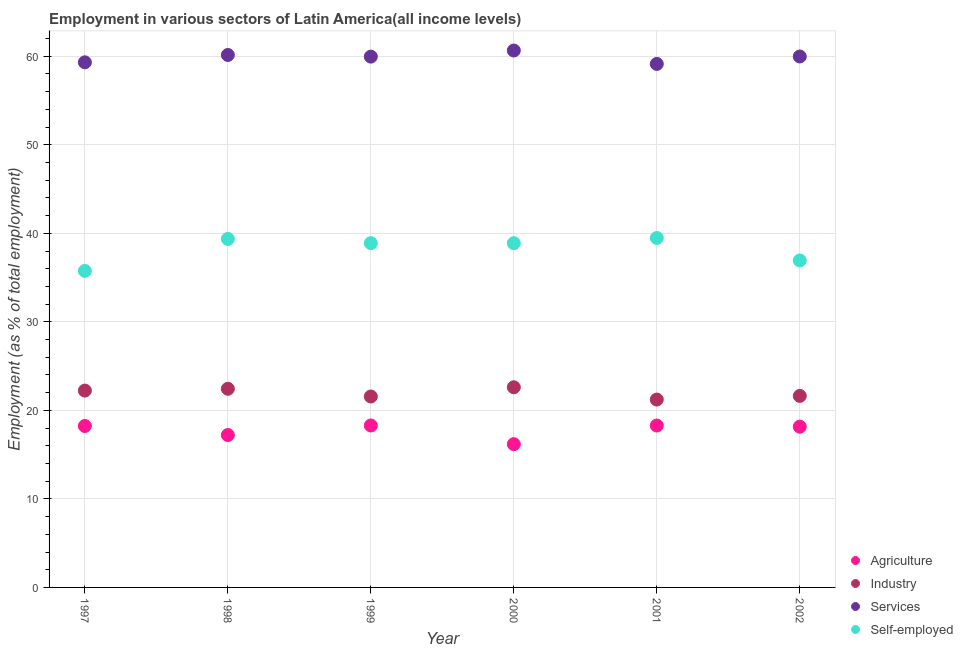How many different coloured dotlines are there?
Provide a succinct answer. 4. What is the percentage of self employed workers in 2002?
Ensure brevity in your answer.  36.93. Across all years, what is the maximum percentage of workers in agriculture?
Your answer should be very brief. 18.29. Across all years, what is the minimum percentage of workers in industry?
Your answer should be very brief. 21.22. In which year was the percentage of workers in industry maximum?
Make the answer very short. 2000. In which year was the percentage of workers in industry minimum?
Provide a succinct answer. 2001. What is the total percentage of self employed workers in the graph?
Keep it short and to the point. 229.3. What is the difference between the percentage of self employed workers in 1997 and that in 1999?
Keep it short and to the point. -3.13. What is the difference between the percentage of workers in services in 2001 and the percentage of self employed workers in 2002?
Make the answer very short. 22.2. What is the average percentage of self employed workers per year?
Provide a short and direct response. 38.22. In the year 1997, what is the difference between the percentage of workers in agriculture and percentage of workers in industry?
Provide a short and direct response. -4. What is the ratio of the percentage of workers in agriculture in 1998 to that in 2002?
Your answer should be very brief. 0.95. Is the difference between the percentage of workers in agriculture in 1997 and 1999 greater than the difference between the percentage of self employed workers in 1997 and 1999?
Your answer should be very brief. Yes. What is the difference between the highest and the second highest percentage of self employed workers?
Make the answer very short. 0.11. What is the difference between the highest and the lowest percentage of workers in services?
Give a very brief answer. 1.51. Is it the case that in every year, the sum of the percentage of workers in agriculture and percentage of workers in services is greater than the sum of percentage of self employed workers and percentage of workers in industry?
Ensure brevity in your answer.  Yes. Does the percentage of self employed workers monotonically increase over the years?
Provide a short and direct response. No. How many dotlines are there?
Offer a very short reply. 4. How many years are there in the graph?
Provide a short and direct response. 6. What is the difference between two consecutive major ticks on the Y-axis?
Make the answer very short. 10. Are the values on the major ticks of Y-axis written in scientific E-notation?
Provide a succinct answer. No. How are the legend labels stacked?
Provide a succinct answer. Vertical. What is the title of the graph?
Ensure brevity in your answer.  Employment in various sectors of Latin America(all income levels). Does "Custom duties" appear as one of the legend labels in the graph?
Offer a terse response. No. What is the label or title of the Y-axis?
Ensure brevity in your answer.  Employment (as % of total employment). What is the Employment (as % of total employment) in Agriculture in 1997?
Your answer should be compact. 18.24. What is the Employment (as % of total employment) of Industry in 1997?
Ensure brevity in your answer.  22.23. What is the Employment (as % of total employment) of Services in 1997?
Make the answer very short. 59.31. What is the Employment (as % of total employment) of Self-employed in 1997?
Your response must be concise. 35.75. What is the Employment (as % of total employment) of Agriculture in 1998?
Your answer should be very brief. 17.21. What is the Employment (as % of total employment) of Industry in 1998?
Offer a terse response. 22.44. What is the Employment (as % of total employment) in Services in 1998?
Ensure brevity in your answer.  60.14. What is the Employment (as % of total employment) in Self-employed in 1998?
Make the answer very short. 39.37. What is the Employment (as % of total employment) in Agriculture in 1999?
Keep it short and to the point. 18.29. What is the Employment (as % of total employment) of Industry in 1999?
Provide a succinct answer. 21.57. What is the Employment (as % of total employment) of Services in 1999?
Your response must be concise. 59.96. What is the Employment (as % of total employment) in Self-employed in 1999?
Make the answer very short. 38.89. What is the Employment (as % of total employment) in Agriculture in 2000?
Provide a succinct answer. 16.18. What is the Employment (as % of total employment) in Industry in 2000?
Your answer should be compact. 22.61. What is the Employment (as % of total employment) of Services in 2000?
Offer a very short reply. 60.65. What is the Employment (as % of total employment) of Self-employed in 2000?
Provide a succinct answer. 38.88. What is the Employment (as % of total employment) of Agriculture in 2001?
Offer a very short reply. 18.29. What is the Employment (as % of total employment) in Industry in 2001?
Provide a short and direct response. 21.22. What is the Employment (as % of total employment) of Services in 2001?
Offer a very short reply. 59.13. What is the Employment (as % of total employment) in Self-employed in 2001?
Provide a short and direct response. 39.47. What is the Employment (as % of total employment) of Agriculture in 2002?
Make the answer very short. 18.16. What is the Employment (as % of total employment) of Industry in 2002?
Offer a very short reply. 21.63. What is the Employment (as % of total employment) of Services in 2002?
Provide a succinct answer. 59.97. What is the Employment (as % of total employment) of Self-employed in 2002?
Ensure brevity in your answer.  36.93. Across all years, what is the maximum Employment (as % of total employment) of Agriculture?
Offer a very short reply. 18.29. Across all years, what is the maximum Employment (as % of total employment) in Industry?
Provide a succinct answer. 22.61. Across all years, what is the maximum Employment (as % of total employment) in Services?
Your answer should be very brief. 60.65. Across all years, what is the maximum Employment (as % of total employment) in Self-employed?
Your answer should be compact. 39.47. Across all years, what is the minimum Employment (as % of total employment) of Agriculture?
Your answer should be compact. 16.18. Across all years, what is the minimum Employment (as % of total employment) of Industry?
Offer a terse response. 21.22. Across all years, what is the minimum Employment (as % of total employment) of Services?
Your response must be concise. 59.13. Across all years, what is the minimum Employment (as % of total employment) of Self-employed?
Provide a succinct answer. 35.75. What is the total Employment (as % of total employment) of Agriculture in the graph?
Offer a very short reply. 106.37. What is the total Employment (as % of total employment) of Industry in the graph?
Offer a very short reply. 131.7. What is the total Employment (as % of total employment) in Services in the graph?
Provide a succinct answer. 359.16. What is the total Employment (as % of total employment) in Self-employed in the graph?
Your response must be concise. 229.3. What is the difference between the Employment (as % of total employment) of Agriculture in 1997 and that in 1998?
Provide a short and direct response. 1.02. What is the difference between the Employment (as % of total employment) of Industry in 1997 and that in 1998?
Your response must be concise. -0.21. What is the difference between the Employment (as % of total employment) of Services in 1997 and that in 1998?
Offer a very short reply. -0.83. What is the difference between the Employment (as % of total employment) of Self-employed in 1997 and that in 1998?
Your answer should be very brief. -3.61. What is the difference between the Employment (as % of total employment) in Agriculture in 1997 and that in 1999?
Your answer should be very brief. -0.06. What is the difference between the Employment (as % of total employment) in Industry in 1997 and that in 1999?
Make the answer very short. 0.67. What is the difference between the Employment (as % of total employment) in Services in 1997 and that in 1999?
Keep it short and to the point. -0.64. What is the difference between the Employment (as % of total employment) in Self-employed in 1997 and that in 1999?
Your answer should be very brief. -3.13. What is the difference between the Employment (as % of total employment) in Agriculture in 1997 and that in 2000?
Keep it short and to the point. 2.05. What is the difference between the Employment (as % of total employment) of Industry in 1997 and that in 2000?
Offer a terse response. -0.38. What is the difference between the Employment (as % of total employment) of Services in 1997 and that in 2000?
Make the answer very short. -1.33. What is the difference between the Employment (as % of total employment) of Self-employed in 1997 and that in 2000?
Provide a short and direct response. -3.13. What is the difference between the Employment (as % of total employment) of Agriculture in 1997 and that in 2001?
Your answer should be compact. -0.05. What is the difference between the Employment (as % of total employment) in Industry in 1997 and that in 2001?
Your answer should be compact. 1.01. What is the difference between the Employment (as % of total employment) in Services in 1997 and that in 2001?
Make the answer very short. 0.18. What is the difference between the Employment (as % of total employment) in Self-employed in 1997 and that in 2001?
Provide a succinct answer. -3.72. What is the difference between the Employment (as % of total employment) of Agriculture in 1997 and that in 2002?
Offer a terse response. 0.08. What is the difference between the Employment (as % of total employment) in Industry in 1997 and that in 2002?
Keep it short and to the point. 0.6. What is the difference between the Employment (as % of total employment) in Services in 1997 and that in 2002?
Offer a terse response. -0.66. What is the difference between the Employment (as % of total employment) of Self-employed in 1997 and that in 2002?
Provide a succinct answer. -1.18. What is the difference between the Employment (as % of total employment) in Agriculture in 1998 and that in 1999?
Your response must be concise. -1.08. What is the difference between the Employment (as % of total employment) in Industry in 1998 and that in 1999?
Offer a terse response. 0.87. What is the difference between the Employment (as % of total employment) of Services in 1998 and that in 1999?
Make the answer very short. 0.18. What is the difference between the Employment (as % of total employment) in Self-employed in 1998 and that in 1999?
Your answer should be very brief. 0.48. What is the difference between the Employment (as % of total employment) in Agriculture in 1998 and that in 2000?
Offer a terse response. 1.03. What is the difference between the Employment (as % of total employment) of Industry in 1998 and that in 2000?
Your answer should be compact. -0.17. What is the difference between the Employment (as % of total employment) of Services in 1998 and that in 2000?
Provide a succinct answer. -0.51. What is the difference between the Employment (as % of total employment) of Self-employed in 1998 and that in 2000?
Offer a terse response. 0.49. What is the difference between the Employment (as % of total employment) in Agriculture in 1998 and that in 2001?
Your response must be concise. -1.07. What is the difference between the Employment (as % of total employment) of Industry in 1998 and that in 2001?
Your response must be concise. 1.22. What is the difference between the Employment (as % of total employment) in Services in 1998 and that in 2001?
Your answer should be compact. 1.01. What is the difference between the Employment (as % of total employment) of Self-employed in 1998 and that in 2001?
Give a very brief answer. -0.11. What is the difference between the Employment (as % of total employment) in Agriculture in 1998 and that in 2002?
Your answer should be very brief. -0.94. What is the difference between the Employment (as % of total employment) of Industry in 1998 and that in 2002?
Give a very brief answer. 0.81. What is the difference between the Employment (as % of total employment) of Services in 1998 and that in 2002?
Your answer should be very brief. 0.17. What is the difference between the Employment (as % of total employment) in Self-employed in 1998 and that in 2002?
Your answer should be very brief. 2.44. What is the difference between the Employment (as % of total employment) of Agriculture in 1999 and that in 2000?
Your response must be concise. 2.11. What is the difference between the Employment (as % of total employment) in Industry in 1999 and that in 2000?
Ensure brevity in your answer.  -1.04. What is the difference between the Employment (as % of total employment) of Services in 1999 and that in 2000?
Offer a terse response. -0.69. What is the difference between the Employment (as % of total employment) of Self-employed in 1999 and that in 2000?
Offer a very short reply. 0.01. What is the difference between the Employment (as % of total employment) of Agriculture in 1999 and that in 2001?
Make the answer very short. 0.01. What is the difference between the Employment (as % of total employment) of Industry in 1999 and that in 2001?
Your response must be concise. 0.34. What is the difference between the Employment (as % of total employment) of Services in 1999 and that in 2001?
Give a very brief answer. 0.82. What is the difference between the Employment (as % of total employment) in Self-employed in 1999 and that in 2001?
Keep it short and to the point. -0.59. What is the difference between the Employment (as % of total employment) of Agriculture in 1999 and that in 2002?
Your answer should be very brief. 0.14. What is the difference between the Employment (as % of total employment) of Industry in 1999 and that in 2002?
Offer a terse response. -0.07. What is the difference between the Employment (as % of total employment) of Services in 1999 and that in 2002?
Provide a succinct answer. -0.02. What is the difference between the Employment (as % of total employment) in Self-employed in 1999 and that in 2002?
Provide a short and direct response. 1.96. What is the difference between the Employment (as % of total employment) in Agriculture in 2000 and that in 2001?
Ensure brevity in your answer.  -2.11. What is the difference between the Employment (as % of total employment) of Industry in 2000 and that in 2001?
Offer a very short reply. 1.39. What is the difference between the Employment (as % of total employment) in Services in 2000 and that in 2001?
Make the answer very short. 1.51. What is the difference between the Employment (as % of total employment) in Self-employed in 2000 and that in 2001?
Give a very brief answer. -0.59. What is the difference between the Employment (as % of total employment) in Agriculture in 2000 and that in 2002?
Make the answer very short. -1.98. What is the difference between the Employment (as % of total employment) of Industry in 2000 and that in 2002?
Offer a terse response. 0.98. What is the difference between the Employment (as % of total employment) of Services in 2000 and that in 2002?
Make the answer very short. 0.67. What is the difference between the Employment (as % of total employment) in Self-employed in 2000 and that in 2002?
Offer a terse response. 1.95. What is the difference between the Employment (as % of total employment) of Agriculture in 2001 and that in 2002?
Your answer should be compact. 0.13. What is the difference between the Employment (as % of total employment) in Industry in 2001 and that in 2002?
Ensure brevity in your answer.  -0.41. What is the difference between the Employment (as % of total employment) of Services in 2001 and that in 2002?
Make the answer very short. -0.84. What is the difference between the Employment (as % of total employment) in Self-employed in 2001 and that in 2002?
Offer a terse response. 2.54. What is the difference between the Employment (as % of total employment) of Agriculture in 1997 and the Employment (as % of total employment) of Industry in 1998?
Your answer should be compact. -4.2. What is the difference between the Employment (as % of total employment) in Agriculture in 1997 and the Employment (as % of total employment) in Services in 1998?
Provide a short and direct response. -41.91. What is the difference between the Employment (as % of total employment) in Agriculture in 1997 and the Employment (as % of total employment) in Self-employed in 1998?
Make the answer very short. -21.13. What is the difference between the Employment (as % of total employment) in Industry in 1997 and the Employment (as % of total employment) in Services in 1998?
Keep it short and to the point. -37.91. What is the difference between the Employment (as % of total employment) in Industry in 1997 and the Employment (as % of total employment) in Self-employed in 1998?
Offer a very short reply. -17.13. What is the difference between the Employment (as % of total employment) of Services in 1997 and the Employment (as % of total employment) of Self-employed in 1998?
Your answer should be compact. 19.95. What is the difference between the Employment (as % of total employment) in Agriculture in 1997 and the Employment (as % of total employment) in Industry in 1999?
Offer a very short reply. -3.33. What is the difference between the Employment (as % of total employment) of Agriculture in 1997 and the Employment (as % of total employment) of Services in 1999?
Provide a succinct answer. -41.72. What is the difference between the Employment (as % of total employment) of Agriculture in 1997 and the Employment (as % of total employment) of Self-employed in 1999?
Make the answer very short. -20.65. What is the difference between the Employment (as % of total employment) of Industry in 1997 and the Employment (as % of total employment) of Services in 1999?
Provide a succinct answer. -37.72. What is the difference between the Employment (as % of total employment) in Industry in 1997 and the Employment (as % of total employment) in Self-employed in 1999?
Provide a short and direct response. -16.65. What is the difference between the Employment (as % of total employment) of Services in 1997 and the Employment (as % of total employment) of Self-employed in 1999?
Your response must be concise. 20.43. What is the difference between the Employment (as % of total employment) in Agriculture in 1997 and the Employment (as % of total employment) in Industry in 2000?
Offer a terse response. -4.37. What is the difference between the Employment (as % of total employment) in Agriculture in 1997 and the Employment (as % of total employment) in Services in 2000?
Offer a very short reply. -42.41. What is the difference between the Employment (as % of total employment) in Agriculture in 1997 and the Employment (as % of total employment) in Self-employed in 2000?
Keep it short and to the point. -20.65. What is the difference between the Employment (as % of total employment) of Industry in 1997 and the Employment (as % of total employment) of Services in 2000?
Provide a succinct answer. -38.41. What is the difference between the Employment (as % of total employment) in Industry in 1997 and the Employment (as % of total employment) in Self-employed in 2000?
Ensure brevity in your answer.  -16.65. What is the difference between the Employment (as % of total employment) of Services in 1997 and the Employment (as % of total employment) of Self-employed in 2000?
Your response must be concise. 20.43. What is the difference between the Employment (as % of total employment) of Agriculture in 1997 and the Employment (as % of total employment) of Industry in 2001?
Make the answer very short. -2.99. What is the difference between the Employment (as % of total employment) in Agriculture in 1997 and the Employment (as % of total employment) in Services in 2001?
Make the answer very short. -40.9. What is the difference between the Employment (as % of total employment) in Agriculture in 1997 and the Employment (as % of total employment) in Self-employed in 2001?
Provide a succinct answer. -21.24. What is the difference between the Employment (as % of total employment) of Industry in 1997 and the Employment (as % of total employment) of Services in 2001?
Offer a very short reply. -36.9. What is the difference between the Employment (as % of total employment) in Industry in 1997 and the Employment (as % of total employment) in Self-employed in 2001?
Offer a terse response. -17.24. What is the difference between the Employment (as % of total employment) in Services in 1997 and the Employment (as % of total employment) in Self-employed in 2001?
Offer a very short reply. 19.84. What is the difference between the Employment (as % of total employment) of Agriculture in 1997 and the Employment (as % of total employment) of Industry in 2002?
Ensure brevity in your answer.  -3.4. What is the difference between the Employment (as % of total employment) of Agriculture in 1997 and the Employment (as % of total employment) of Services in 2002?
Make the answer very short. -41.74. What is the difference between the Employment (as % of total employment) in Agriculture in 1997 and the Employment (as % of total employment) in Self-employed in 2002?
Ensure brevity in your answer.  -18.7. What is the difference between the Employment (as % of total employment) in Industry in 1997 and the Employment (as % of total employment) in Services in 2002?
Your response must be concise. -37.74. What is the difference between the Employment (as % of total employment) in Industry in 1997 and the Employment (as % of total employment) in Self-employed in 2002?
Your answer should be compact. -14.7. What is the difference between the Employment (as % of total employment) in Services in 1997 and the Employment (as % of total employment) in Self-employed in 2002?
Provide a short and direct response. 22.38. What is the difference between the Employment (as % of total employment) of Agriculture in 1998 and the Employment (as % of total employment) of Industry in 1999?
Provide a short and direct response. -4.35. What is the difference between the Employment (as % of total employment) in Agriculture in 1998 and the Employment (as % of total employment) in Services in 1999?
Keep it short and to the point. -42.74. What is the difference between the Employment (as % of total employment) in Agriculture in 1998 and the Employment (as % of total employment) in Self-employed in 1999?
Your response must be concise. -21.67. What is the difference between the Employment (as % of total employment) of Industry in 1998 and the Employment (as % of total employment) of Services in 1999?
Offer a very short reply. -37.52. What is the difference between the Employment (as % of total employment) in Industry in 1998 and the Employment (as % of total employment) in Self-employed in 1999?
Offer a terse response. -16.45. What is the difference between the Employment (as % of total employment) of Services in 1998 and the Employment (as % of total employment) of Self-employed in 1999?
Your answer should be very brief. 21.25. What is the difference between the Employment (as % of total employment) in Agriculture in 1998 and the Employment (as % of total employment) in Industry in 2000?
Give a very brief answer. -5.4. What is the difference between the Employment (as % of total employment) in Agriculture in 1998 and the Employment (as % of total employment) in Services in 2000?
Make the answer very short. -43.43. What is the difference between the Employment (as % of total employment) in Agriculture in 1998 and the Employment (as % of total employment) in Self-employed in 2000?
Your response must be concise. -21.67. What is the difference between the Employment (as % of total employment) of Industry in 1998 and the Employment (as % of total employment) of Services in 2000?
Give a very brief answer. -38.21. What is the difference between the Employment (as % of total employment) of Industry in 1998 and the Employment (as % of total employment) of Self-employed in 2000?
Make the answer very short. -16.44. What is the difference between the Employment (as % of total employment) of Services in 1998 and the Employment (as % of total employment) of Self-employed in 2000?
Make the answer very short. 21.26. What is the difference between the Employment (as % of total employment) in Agriculture in 1998 and the Employment (as % of total employment) in Industry in 2001?
Your response must be concise. -4.01. What is the difference between the Employment (as % of total employment) in Agriculture in 1998 and the Employment (as % of total employment) in Services in 2001?
Provide a succinct answer. -41.92. What is the difference between the Employment (as % of total employment) of Agriculture in 1998 and the Employment (as % of total employment) of Self-employed in 2001?
Keep it short and to the point. -22.26. What is the difference between the Employment (as % of total employment) of Industry in 1998 and the Employment (as % of total employment) of Services in 2001?
Provide a succinct answer. -36.69. What is the difference between the Employment (as % of total employment) of Industry in 1998 and the Employment (as % of total employment) of Self-employed in 2001?
Offer a very short reply. -17.04. What is the difference between the Employment (as % of total employment) of Services in 1998 and the Employment (as % of total employment) of Self-employed in 2001?
Your answer should be compact. 20.67. What is the difference between the Employment (as % of total employment) of Agriculture in 1998 and the Employment (as % of total employment) of Industry in 2002?
Your response must be concise. -4.42. What is the difference between the Employment (as % of total employment) of Agriculture in 1998 and the Employment (as % of total employment) of Services in 2002?
Make the answer very short. -42.76. What is the difference between the Employment (as % of total employment) in Agriculture in 1998 and the Employment (as % of total employment) in Self-employed in 2002?
Make the answer very short. -19.72. What is the difference between the Employment (as % of total employment) of Industry in 1998 and the Employment (as % of total employment) of Services in 2002?
Give a very brief answer. -37.53. What is the difference between the Employment (as % of total employment) in Industry in 1998 and the Employment (as % of total employment) in Self-employed in 2002?
Offer a terse response. -14.49. What is the difference between the Employment (as % of total employment) of Services in 1998 and the Employment (as % of total employment) of Self-employed in 2002?
Your answer should be compact. 23.21. What is the difference between the Employment (as % of total employment) in Agriculture in 1999 and the Employment (as % of total employment) in Industry in 2000?
Offer a very short reply. -4.32. What is the difference between the Employment (as % of total employment) of Agriculture in 1999 and the Employment (as % of total employment) of Services in 2000?
Give a very brief answer. -42.35. What is the difference between the Employment (as % of total employment) in Agriculture in 1999 and the Employment (as % of total employment) in Self-employed in 2000?
Keep it short and to the point. -20.59. What is the difference between the Employment (as % of total employment) in Industry in 1999 and the Employment (as % of total employment) in Services in 2000?
Provide a short and direct response. -39.08. What is the difference between the Employment (as % of total employment) in Industry in 1999 and the Employment (as % of total employment) in Self-employed in 2000?
Give a very brief answer. -17.32. What is the difference between the Employment (as % of total employment) in Services in 1999 and the Employment (as % of total employment) in Self-employed in 2000?
Keep it short and to the point. 21.08. What is the difference between the Employment (as % of total employment) of Agriculture in 1999 and the Employment (as % of total employment) of Industry in 2001?
Provide a succinct answer. -2.93. What is the difference between the Employment (as % of total employment) of Agriculture in 1999 and the Employment (as % of total employment) of Services in 2001?
Your answer should be compact. -40.84. What is the difference between the Employment (as % of total employment) of Agriculture in 1999 and the Employment (as % of total employment) of Self-employed in 2001?
Make the answer very short. -21.18. What is the difference between the Employment (as % of total employment) in Industry in 1999 and the Employment (as % of total employment) in Services in 2001?
Provide a short and direct response. -37.57. What is the difference between the Employment (as % of total employment) of Industry in 1999 and the Employment (as % of total employment) of Self-employed in 2001?
Your response must be concise. -17.91. What is the difference between the Employment (as % of total employment) of Services in 1999 and the Employment (as % of total employment) of Self-employed in 2001?
Offer a very short reply. 20.48. What is the difference between the Employment (as % of total employment) in Agriculture in 1999 and the Employment (as % of total employment) in Industry in 2002?
Ensure brevity in your answer.  -3.34. What is the difference between the Employment (as % of total employment) in Agriculture in 1999 and the Employment (as % of total employment) in Services in 2002?
Your answer should be compact. -41.68. What is the difference between the Employment (as % of total employment) in Agriculture in 1999 and the Employment (as % of total employment) in Self-employed in 2002?
Keep it short and to the point. -18.64. What is the difference between the Employment (as % of total employment) of Industry in 1999 and the Employment (as % of total employment) of Services in 2002?
Give a very brief answer. -38.41. What is the difference between the Employment (as % of total employment) in Industry in 1999 and the Employment (as % of total employment) in Self-employed in 2002?
Your answer should be compact. -15.37. What is the difference between the Employment (as % of total employment) in Services in 1999 and the Employment (as % of total employment) in Self-employed in 2002?
Offer a very short reply. 23.02. What is the difference between the Employment (as % of total employment) in Agriculture in 2000 and the Employment (as % of total employment) in Industry in 2001?
Provide a succinct answer. -5.04. What is the difference between the Employment (as % of total employment) in Agriculture in 2000 and the Employment (as % of total employment) in Services in 2001?
Your answer should be compact. -42.95. What is the difference between the Employment (as % of total employment) of Agriculture in 2000 and the Employment (as % of total employment) of Self-employed in 2001?
Your answer should be compact. -23.29. What is the difference between the Employment (as % of total employment) of Industry in 2000 and the Employment (as % of total employment) of Services in 2001?
Your answer should be very brief. -36.52. What is the difference between the Employment (as % of total employment) of Industry in 2000 and the Employment (as % of total employment) of Self-employed in 2001?
Your response must be concise. -16.86. What is the difference between the Employment (as % of total employment) of Services in 2000 and the Employment (as % of total employment) of Self-employed in 2001?
Provide a short and direct response. 21.17. What is the difference between the Employment (as % of total employment) of Agriculture in 2000 and the Employment (as % of total employment) of Industry in 2002?
Your answer should be compact. -5.45. What is the difference between the Employment (as % of total employment) in Agriculture in 2000 and the Employment (as % of total employment) in Services in 2002?
Your response must be concise. -43.79. What is the difference between the Employment (as % of total employment) in Agriculture in 2000 and the Employment (as % of total employment) in Self-employed in 2002?
Your response must be concise. -20.75. What is the difference between the Employment (as % of total employment) of Industry in 2000 and the Employment (as % of total employment) of Services in 2002?
Your answer should be compact. -37.36. What is the difference between the Employment (as % of total employment) of Industry in 2000 and the Employment (as % of total employment) of Self-employed in 2002?
Make the answer very short. -14.32. What is the difference between the Employment (as % of total employment) of Services in 2000 and the Employment (as % of total employment) of Self-employed in 2002?
Offer a terse response. 23.71. What is the difference between the Employment (as % of total employment) in Agriculture in 2001 and the Employment (as % of total employment) in Industry in 2002?
Give a very brief answer. -3.35. What is the difference between the Employment (as % of total employment) of Agriculture in 2001 and the Employment (as % of total employment) of Services in 2002?
Your answer should be compact. -41.69. What is the difference between the Employment (as % of total employment) in Agriculture in 2001 and the Employment (as % of total employment) in Self-employed in 2002?
Offer a terse response. -18.65. What is the difference between the Employment (as % of total employment) of Industry in 2001 and the Employment (as % of total employment) of Services in 2002?
Offer a terse response. -38.75. What is the difference between the Employment (as % of total employment) of Industry in 2001 and the Employment (as % of total employment) of Self-employed in 2002?
Provide a short and direct response. -15.71. What is the difference between the Employment (as % of total employment) in Services in 2001 and the Employment (as % of total employment) in Self-employed in 2002?
Your answer should be very brief. 22.2. What is the average Employment (as % of total employment) of Agriculture per year?
Your response must be concise. 17.73. What is the average Employment (as % of total employment) in Industry per year?
Offer a terse response. 21.95. What is the average Employment (as % of total employment) in Services per year?
Provide a short and direct response. 59.86. What is the average Employment (as % of total employment) of Self-employed per year?
Your response must be concise. 38.22. In the year 1997, what is the difference between the Employment (as % of total employment) of Agriculture and Employment (as % of total employment) of Industry?
Make the answer very short. -4. In the year 1997, what is the difference between the Employment (as % of total employment) in Agriculture and Employment (as % of total employment) in Services?
Ensure brevity in your answer.  -41.08. In the year 1997, what is the difference between the Employment (as % of total employment) of Agriculture and Employment (as % of total employment) of Self-employed?
Provide a short and direct response. -17.52. In the year 1997, what is the difference between the Employment (as % of total employment) of Industry and Employment (as % of total employment) of Services?
Offer a terse response. -37.08. In the year 1997, what is the difference between the Employment (as % of total employment) of Industry and Employment (as % of total employment) of Self-employed?
Offer a very short reply. -13.52. In the year 1997, what is the difference between the Employment (as % of total employment) of Services and Employment (as % of total employment) of Self-employed?
Give a very brief answer. 23.56. In the year 1998, what is the difference between the Employment (as % of total employment) of Agriculture and Employment (as % of total employment) of Industry?
Provide a short and direct response. -5.23. In the year 1998, what is the difference between the Employment (as % of total employment) in Agriculture and Employment (as % of total employment) in Services?
Your response must be concise. -42.93. In the year 1998, what is the difference between the Employment (as % of total employment) of Agriculture and Employment (as % of total employment) of Self-employed?
Offer a very short reply. -22.15. In the year 1998, what is the difference between the Employment (as % of total employment) in Industry and Employment (as % of total employment) in Services?
Make the answer very short. -37.7. In the year 1998, what is the difference between the Employment (as % of total employment) of Industry and Employment (as % of total employment) of Self-employed?
Make the answer very short. -16.93. In the year 1998, what is the difference between the Employment (as % of total employment) of Services and Employment (as % of total employment) of Self-employed?
Provide a short and direct response. 20.77. In the year 1999, what is the difference between the Employment (as % of total employment) in Agriculture and Employment (as % of total employment) in Industry?
Your response must be concise. -3.27. In the year 1999, what is the difference between the Employment (as % of total employment) in Agriculture and Employment (as % of total employment) in Services?
Ensure brevity in your answer.  -41.66. In the year 1999, what is the difference between the Employment (as % of total employment) of Agriculture and Employment (as % of total employment) of Self-employed?
Your response must be concise. -20.59. In the year 1999, what is the difference between the Employment (as % of total employment) of Industry and Employment (as % of total employment) of Services?
Give a very brief answer. -38.39. In the year 1999, what is the difference between the Employment (as % of total employment) of Industry and Employment (as % of total employment) of Self-employed?
Offer a very short reply. -17.32. In the year 1999, what is the difference between the Employment (as % of total employment) of Services and Employment (as % of total employment) of Self-employed?
Ensure brevity in your answer.  21.07. In the year 2000, what is the difference between the Employment (as % of total employment) in Agriculture and Employment (as % of total employment) in Industry?
Provide a succinct answer. -6.43. In the year 2000, what is the difference between the Employment (as % of total employment) of Agriculture and Employment (as % of total employment) of Services?
Your response must be concise. -44.46. In the year 2000, what is the difference between the Employment (as % of total employment) in Agriculture and Employment (as % of total employment) in Self-employed?
Give a very brief answer. -22.7. In the year 2000, what is the difference between the Employment (as % of total employment) of Industry and Employment (as % of total employment) of Services?
Offer a very short reply. -38.04. In the year 2000, what is the difference between the Employment (as % of total employment) in Industry and Employment (as % of total employment) in Self-employed?
Offer a terse response. -16.27. In the year 2000, what is the difference between the Employment (as % of total employment) in Services and Employment (as % of total employment) in Self-employed?
Provide a short and direct response. 21.77. In the year 2001, what is the difference between the Employment (as % of total employment) of Agriculture and Employment (as % of total employment) of Industry?
Make the answer very short. -2.93. In the year 2001, what is the difference between the Employment (as % of total employment) of Agriculture and Employment (as % of total employment) of Services?
Offer a terse response. -40.84. In the year 2001, what is the difference between the Employment (as % of total employment) of Agriculture and Employment (as % of total employment) of Self-employed?
Give a very brief answer. -21.19. In the year 2001, what is the difference between the Employment (as % of total employment) of Industry and Employment (as % of total employment) of Services?
Your response must be concise. -37.91. In the year 2001, what is the difference between the Employment (as % of total employment) of Industry and Employment (as % of total employment) of Self-employed?
Provide a succinct answer. -18.25. In the year 2001, what is the difference between the Employment (as % of total employment) in Services and Employment (as % of total employment) in Self-employed?
Ensure brevity in your answer.  19.66. In the year 2002, what is the difference between the Employment (as % of total employment) in Agriculture and Employment (as % of total employment) in Industry?
Provide a succinct answer. -3.48. In the year 2002, what is the difference between the Employment (as % of total employment) in Agriculture and Employment (as % of total employment) in Services?
Provide a short and direct response. -41.81. In the year 2002, what is the difference between the Employment (as % of total employment) in Agriculture and Employment (as % of total employment) in Self-employed?
Keep it short and to the point. -18.77. In the year 2002, what is the difference between the Employment (as % of total employment) of Industry and Employment (as % of total employment) of Services?
Offer a very short reply. -38.34. In the year 2002, what is the difference between the Employment (as % of total employment) in Industry and Employment (as % of total employment) in Self-employed?
Provide a succinct answer. -15.3. In the year 2002, what is the difference between the Employment (as % of total employment) of Services and Employment (as % of total employment) of Self-employed?
Give a very brief answer. 23.04. What is the ratio of the Employment (as % of total employment) of Agriculture in 1997 to that in 1998?
Ensure brevity in your answer.  1.06. What is the ratio of the Employment (as % of total employment) in Industry in 1997 to that in 1998?
Your answer should be very brief. 0.99. What is the ratio of the Employment (as % of total employment) in Services in 1997 to that in 1998?
Provide a succinct answer. 0.99. What is the ratio of the Employment (as % of total employment) in Self-employed in 1997 to that in 1998?
Offer a very short reply. 0.91. What is the ratio of the Employment (as % of total employment) of Industry in 1997 to that in 1999?
Make the answer very short. 1.03. What is the ratio of the Employment (as % of total employment) in Services in 1997 to that in 1999?
Your answer should be compact. 0.99. What is the ratio of the Employment (as % of total employment) in Self-employed in 1997 to that in 1999?
Offer a terse response. 0.92. What is the ratio of the Employment (as % of total employment) of Agriculture in 1997 to that in 2000?
Give a very brief answer. 1.13. What is the ratio of the Employment (as % of total employment) in Industry in 1997 to that in 2000?
Provide a succinct answer. 0.98. What is the ratio of the Employment (as % of total employment) in Services in 1997 to that in 2000?
Your answer should be very brief. 0.98. What is the ratio of the Employment (as % of total employment) in Self-employed in 1997 to that in 2000?
Keep it short and to the point. 0.92. What is the ratio of the Employment (as % of total employment) of Industry in 1997 to that in 2001?
Offer a very short reply. 1.05. What is the ratio of the Employment (as % of total employment) of Self-employed in 1997 to that in 2001?
Ensure brevity in your answer.  0.91. What is the ratio of the Employment (as % of total employment) in Agriculture in 1997 to that in 2002?
Your response must be concise. 1. What is the ratio of the Employment (as % of total employment) of Industry in 1997 to that in 2002?
Give a very brief answer. 1.03. What is the ratio of the Employment (as % of total employment) of Self-employed in 1997 to that in 2002?
Your answer should be very brief. 0.97. What is the ratio of the Employment (as % of total employment) in Agriculture in 1998 to that in 1999?
Your answer should be compact. 0.94. What is the ratio of the Employment (as % of total employment) in Industry in 1998 to that in 1999?
Make the answer very short. 1.04. What is the ratio of the Employment (as % of total employment) in Services in 1998 to that in 1999?
Make the answer very short. 1. What is the ratio of the Employment (as % of total employment) in Self-employed in 1998 to that in 1999?
Ensure brevity in your answer.  1.01. What is the ratio of the Employment (as % of total employment) in Agriculture in 1998 to that in 2000?
Keep it short and to the point. 1.06. What is the ratio of the Employment (as % of total employment) of Industry in 1998 to that in 2000?
Your answer should be very brief. 0.99. What is the ratio of the Employment (as % of total employment) of Self-employed in 1998 to that in 2000?
Your answer should be compact. 1.01. What is the ratio of the Employment (as % of total employment) in Agriculture in 1998 to that in 2001?
Offer a terse response. 0.94. What is the ratio of the Employment (as % of total employment) in Industry in 1998 to that in 2001?
Provide a short and direct response. 1.06. What is the ratio of the Employment (as % of total employment) in Services in 1998 to that in 2001?
Your answer should be compact. 1.02. What is the ratio of the Employment (as % of total employment) of Agriculture in 1998 to that in 2002?
Give a very brief answer. 0.95. What is the ratio of the Employment (as % of total employment) of Industry in 1998 to that in 2002?
Ensure brevity in your answer.  1.04. What is the ratio of the Employment (as % of total employment) of Services in 1998 to that in 2002?
Offer a very short reply. 1. What is the ratio of the Employment (as % of total employment) of Self-employed in 1998 to that in 2002?
Provide a succinct answer. 1.07. What is the ratio of the Employment (as % of total employment) in Agriculture in 1999 to that in 2000?
Offer a terse response. 1.13. What is the ratio of the Employment (as % of total employment) in Industry in 1999 to that in 2000?
Your answer should be compact. 0.95. What is the ratio of the Employment (as % of total employment) in Services in 1999 to that in 2000?
Your response must be concise. 0.99. What is the ratio of the Employment (as % of total employment) of Self-employed in 1999 to that in 2000?
Keep it short and to the point. 1. What is the ratio of the Employment (as % of total employment) in Industry in 1999 to that in 2001?
Ensure brevity in your answer.  1.02. What is the ratio of the Employment (as % of total employment) in Services in 1999 to that in 2001?
Offer a very short reply. 1.01. What is the ratio of the Employment (as % of total employment) in Self-employed in 1999 to that in 2001?
Provide a short and direct response. 0.99. What is the ratio of the Employment (as % of total employment) in Agriculture in 1999 to that in 2002?
Give a very brief answer. 1.01. What is the ratio of the Employment (as % of total employment) in Industry in 1999 to that in 2002?
Offer a terse response. 1. What is the ratio of the Employment (as % of total employment) of Self-employed in 1999 to that in 2002?
Provide a short and direct response. 1.05. What is the ratio of the Employment (as % of total employment) in Agriculture in 2000 to that in 2001?
Provide a short and direct response. 0.88. What is the ratio of the Employment (as % of total employment) of Industry in 2000 to that in 2001?
Ensure brevity in your answer.  1.07. What is the ratio of the Employment (as % of total employment) in Services in 2000 to that in 2001?
Provide a succinct answer. 1.03. What is the ratio of the Employment (as % of total employment) of Self-employed in 2000 to that in 2001?
Provide a short and direct response. 0.98. What is the ratio of the Employment (as % of total employment) of Agriculture in 2000 to that in 2002?
Ensure brevity in your answer.  0.89. What is the ratio of the Employment (as % of total employment) of Industry in 2000 to that in 2002?
Keep it short and to the point. 1.05. What is the ratio of the Employment (as % of total employment) in Services in 2000 to that in 2002?
Ensure brevity in your answer.  1.01. What is the ratio of the Employment (as % of total employment) of Self-employed in 2000 to that in 2002?
Keep it short and to the point. 1.05. What is the ratio of the Employment (as % of total employment) of Agriculture in 2001 to that in 2002?
Give a very brief answer. 1.01. What is the ratio of the Employment (as % of total employment) of Industry in 2001 to that in 2002?
Give a very brief answer. 0.98. What is the ratio of the Employment (as % of total employment) of Self-employed in 2001 to that in 2002?
Offer a very short reply. 1.07. What is the difference between the highest and the second highest Employment (as % of total employment) of Agriculture?
Your answer should be compact. 0.01. What is the difference between the highest and the second highest Employment (as % of total employment) in Industry?
Offer a terse response. 0.17. What is the difference between the highest and the second highest Employment (as % of total employment) in Services?
Provide a succinct answer. 0.51. What is the difference between the highest and the second highest Employment (as % of total employment) in Self-employed?
Ensure brevity in your answer.  0.11. What is the difference between the highest and the lowest Employment (as % of total employment) of Agriculture?
Keep it short and to the point. 2.11. What is the difference between the highest and the lowest Employment (as % of total employment) in Industry?
Offer a very short reply. 1.39. What is the difference between the highest and the lowest Employment (as % of total employment) in Services?
Keep it short and to the point. 1.51. What is the difference between the highest and the lowest Employment (as % of total employment) in Self-employed?
Provide a succinct answer. 3.72. 